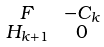<formula> <loc_0><loc_0><loc_500><loc_500>\begin{smallmatrix} F & & - C _ { k } \\ H _ { k + 1 } & & 0 \end{smallmatrix}</formula> 